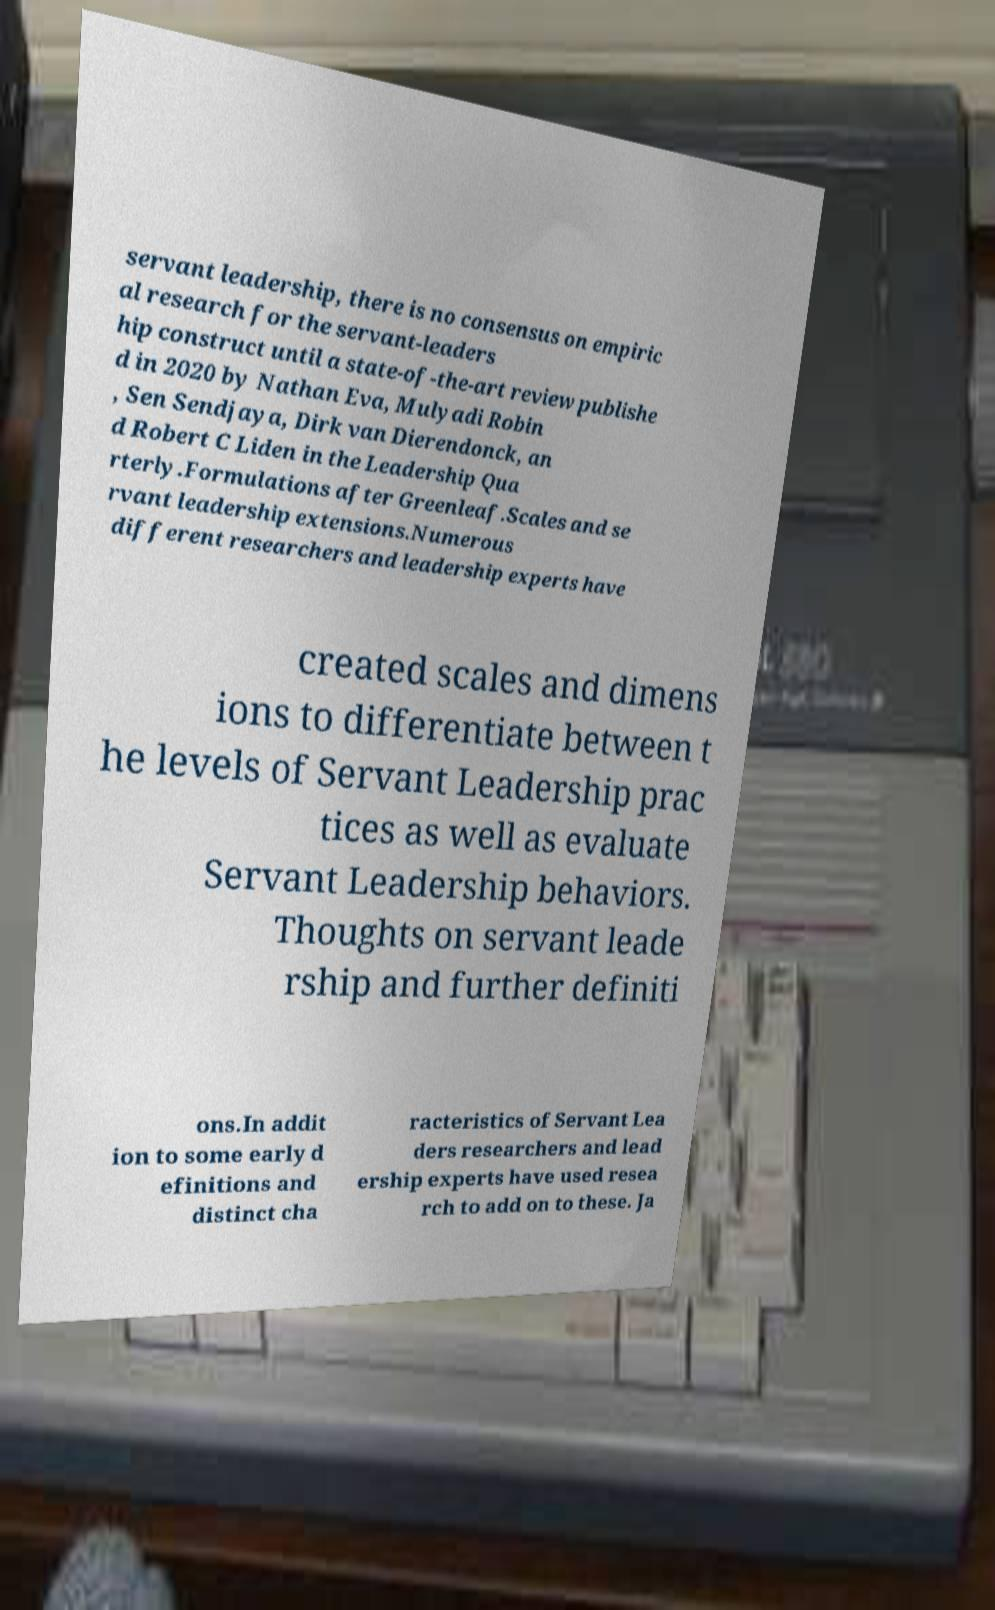Can you read and provide the text displayed in the image?This photo seems to have some interesting text. Can you extract and type it out for me? servant leadership, there is no consensus on empiric al research for the servant-leaders hip construct until a state-of-the-art review publishe d in 2020 by Nathan Eva, Mulyadi Robin , Sen Sendjaya, Dirk van Dierendonck, an d Robert C Liden in the Leadership Qua rterly.Formulations after Greenleaf.Scales and se rvant leadership extensions.Numerous different researchers and leadership experts have created scales and dimens ions to differentiate between t he levels of Servant Leadership prac tices as well as evaluate Servant Leadership behaviors. Thoughts on servant leade rship and further definiti ons.In addit ion to some early d efinitions and distinct cha racteristics of Servant Lea ders researchers and lead ership experts have used resea rch to add on to these. Ja 